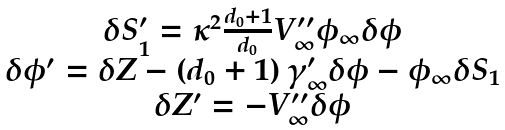Convert formula to latex. <formula><loc_0><loc_0><loc_500><loc_500>\begin{array} { c } \delta S _ { 1 } ^ { \prime } = \kappa ^ { 2 } \frac { d _ { 0 } + 1 } { d _ { 0 } } V _ { \infty } ^ { \prime \prime } \phi _ { \infty } \delta \phi \\ \delta \phi ^ { \prime } = \delta Z - \left ( d _ { 0 } + 1 \right ) \gamma _ { \infty } ^ { \prime } \delta \phi - \phi _ { \infty } \delta S _ { 1 } \\ \delta Z ^ { \prime } = - V _ { \infty } ^ { \prime \prime } \delta \phi \end{array}</formula> 